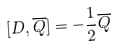Convert formula to latex. <formula><loc_0><loc_0><loc_500><loc_500>[ D , \overline { Q } ] = - \frac { 1 } { 2 } \overline { Q }</formula> 